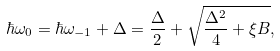Convert formula to latex. <formula><loc_0><loc_0><loc_500><loc_500>\hbar { \omega } _ { 0 } = \hbar { \omega } _ { - 1 } + \Delta = \frac { \Delta } { 2 } + \sqrt { \frac { \Delta ^ { 2 } } { 4 } + \xi B } ,</formula> 